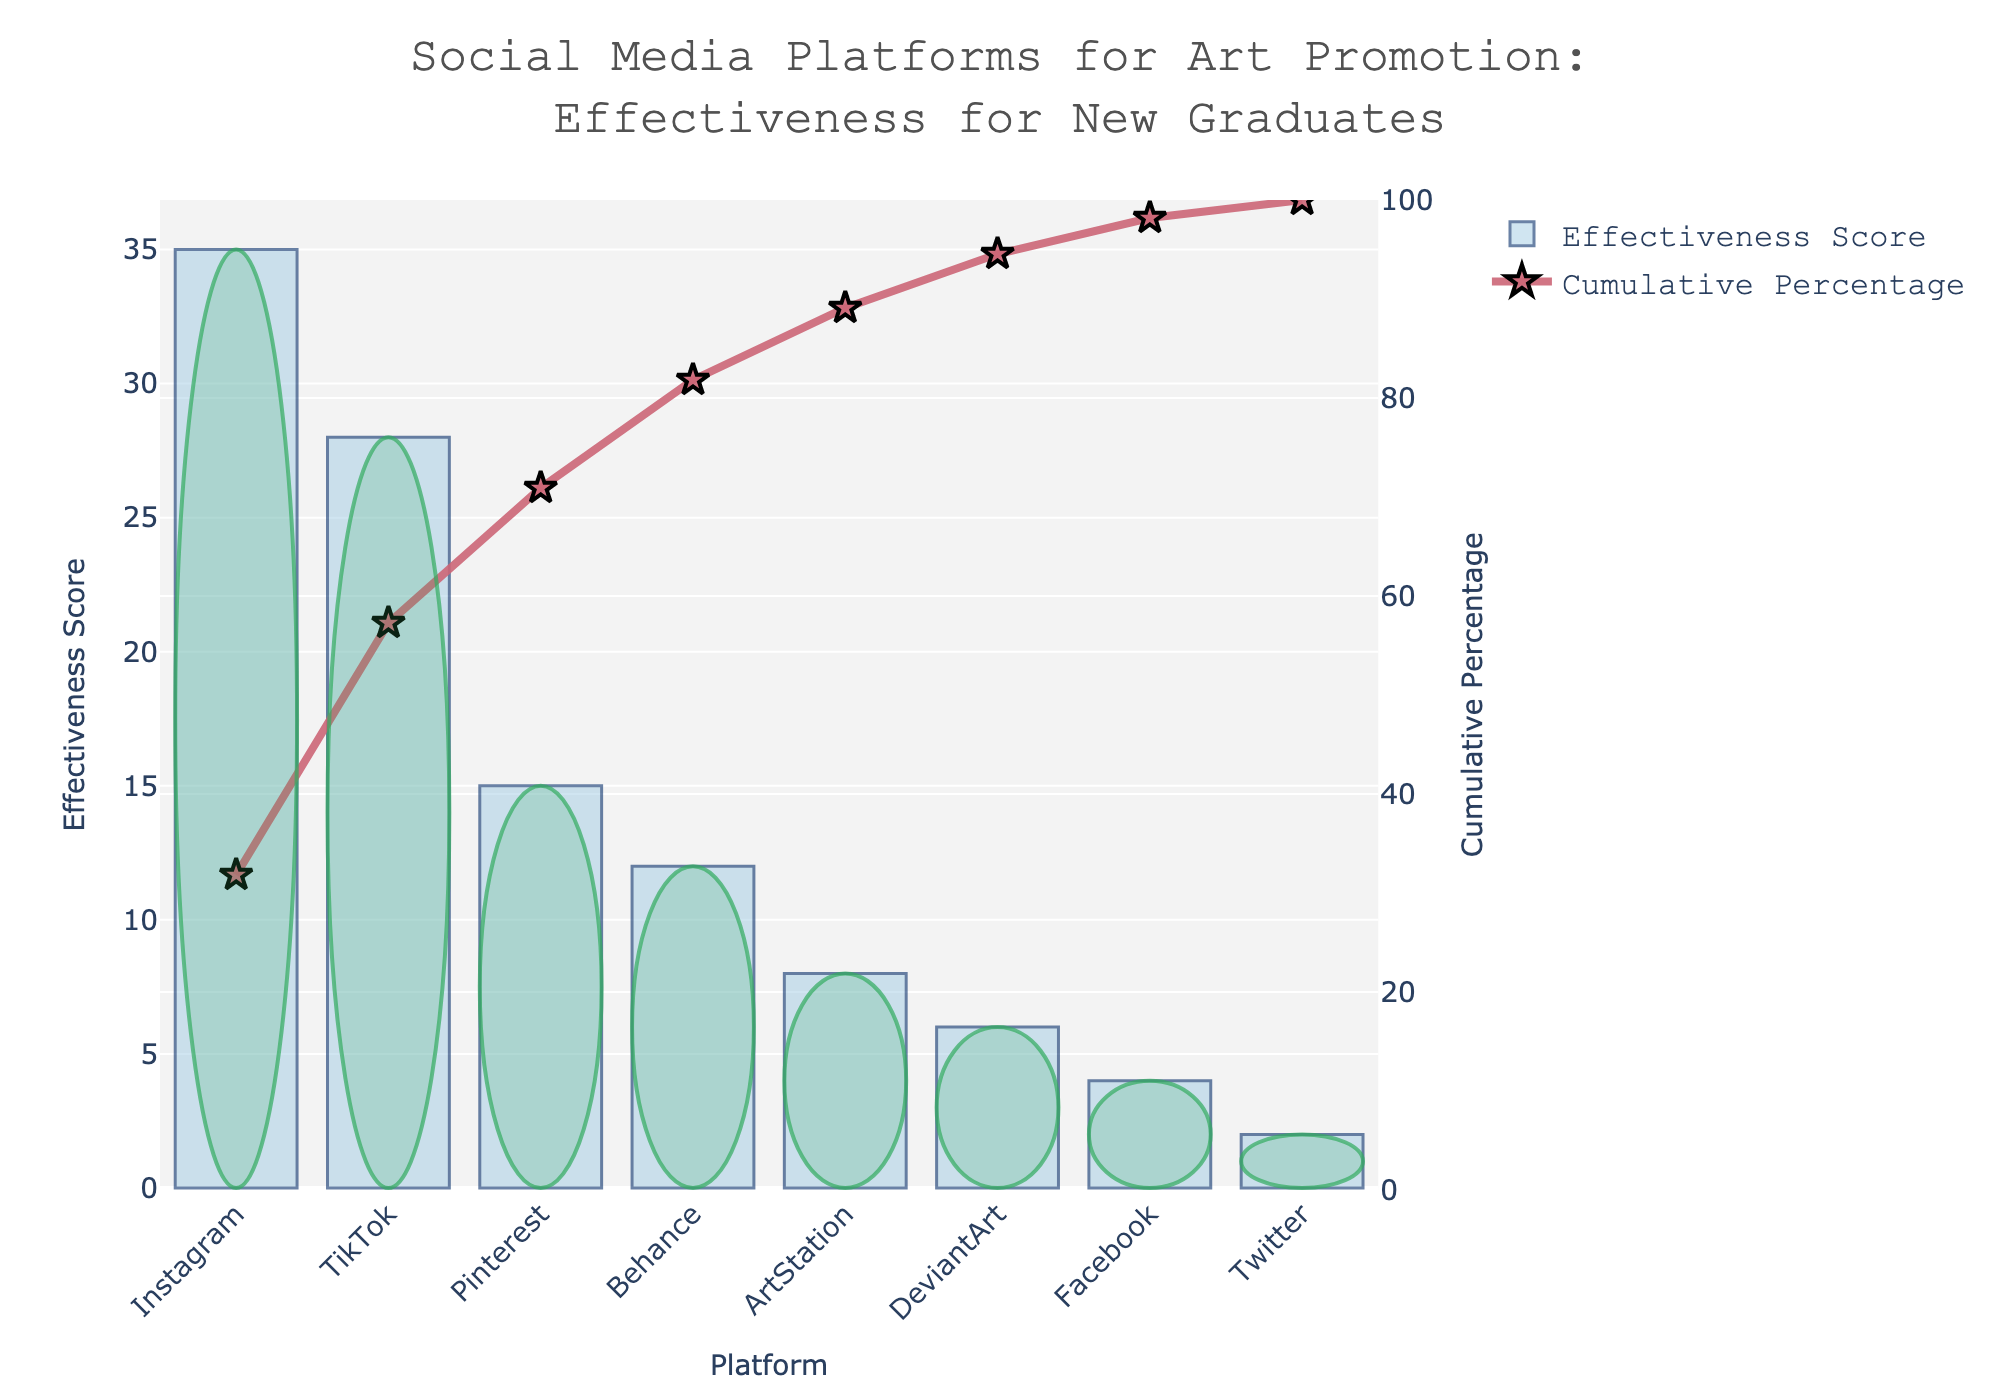Which platform has the highest effectiveness score? Look at the bar heights on the figure and the highest bar represents the platform with the highest effectiveness score.
Answer: Instagram Which three platforms contribute the most to the cumulative percentage? The first three points on the cumulative percentage line represent the platforms that contribute the most. Correspond to these points with the platforms they represent on the x-axis.
Answer: Instagram, TikTok, Pinterest What is the cumulative percentage for the top two platforms? Sum the effectiveness scores of the top two platforms and divide by the total effectiveness score. Multiply by 100 to get the cumulative percentage. Instagram (35) + TikTok (28) = 63, Total = 110, so (63/110)*100 ≈ 57.27%
Answer: 57.27% Which platform is right at the Pareto critical point of 80% cumulative effectiveness? The Pareto critical point at 80% can be found on the cumulative percentage line graph. Trace that point back to the corresponding platform on the x-axis.
Answer: ArtStation How many platforms in total are shown in the figure? Count the number of bars on the x-axis of the bar chart to get the total number of platforms.
Answer: 8 What is the effectiveness score difference between Pinterest and Facebook? Find the heights of the bars corresponding to Pinterest and Facebook, then subtract the smaller from the larger. Pinterest (15) - Facebook (4) = 11
Answer: 11 Which platform has the lowest effectiveness score? Look for the shortest bar in the bar chart to identify the platform with the lowest effectiveness score.
Answer: Twitter What cumulative percentage do the top four platforms account for? Sum the effectiveness scores of the top four platforms, then divide by the total effectiveness score, and multiply by 100. Instagram (35) + TikTok (28) + Pinterest (15) + Behance (12) = 90, Total = 110, so (90/110)*100 ≈ 81.82%
Answer: 81.82% Which platforms have an effectiveness score below 10? Look for bars shorter than the 10 mark on the y-axis of the bar chart to identify the platforms.
Answer: ArtStation, DeviantArt, Facebook, Twitter 